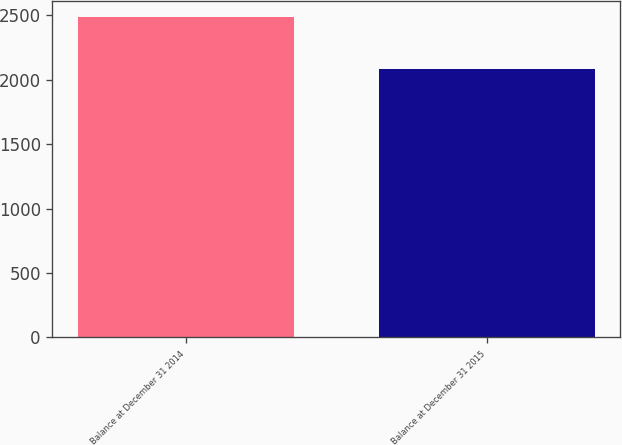Convert chart. <chart><loc_0><loc_0><loc_500><loc_500><bar_chart><fcel>Balance at December 31 2014<fcel>Balance at December 31 2015<nl><fcel>2488<fcel>2085<nl></chart> 